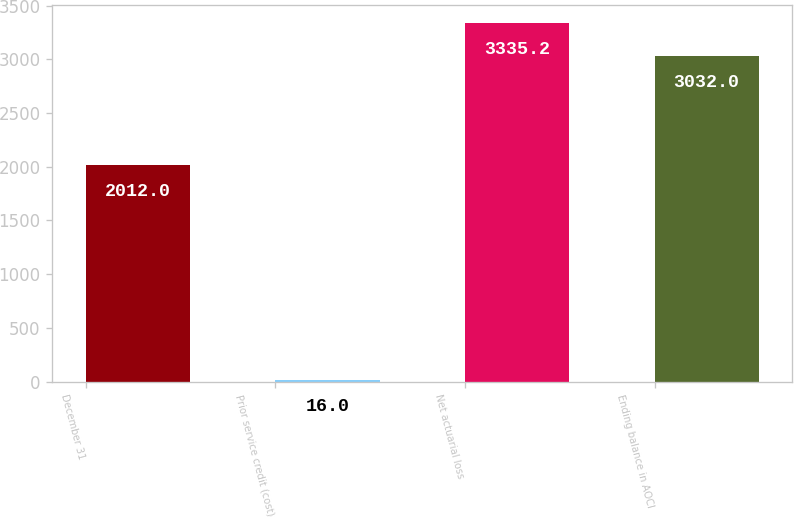<chart> <loc_0><loc_0><loc_500><loc_500><bar_chart><fcel>December 31<fcel>Prior service credit (cost)<fcel>Net actuarial loss<fcel>Ending balance in AOCI<nl><fcel>2012<fcel>16<fcel>3335.2<fcel>3032<nl></chart> 